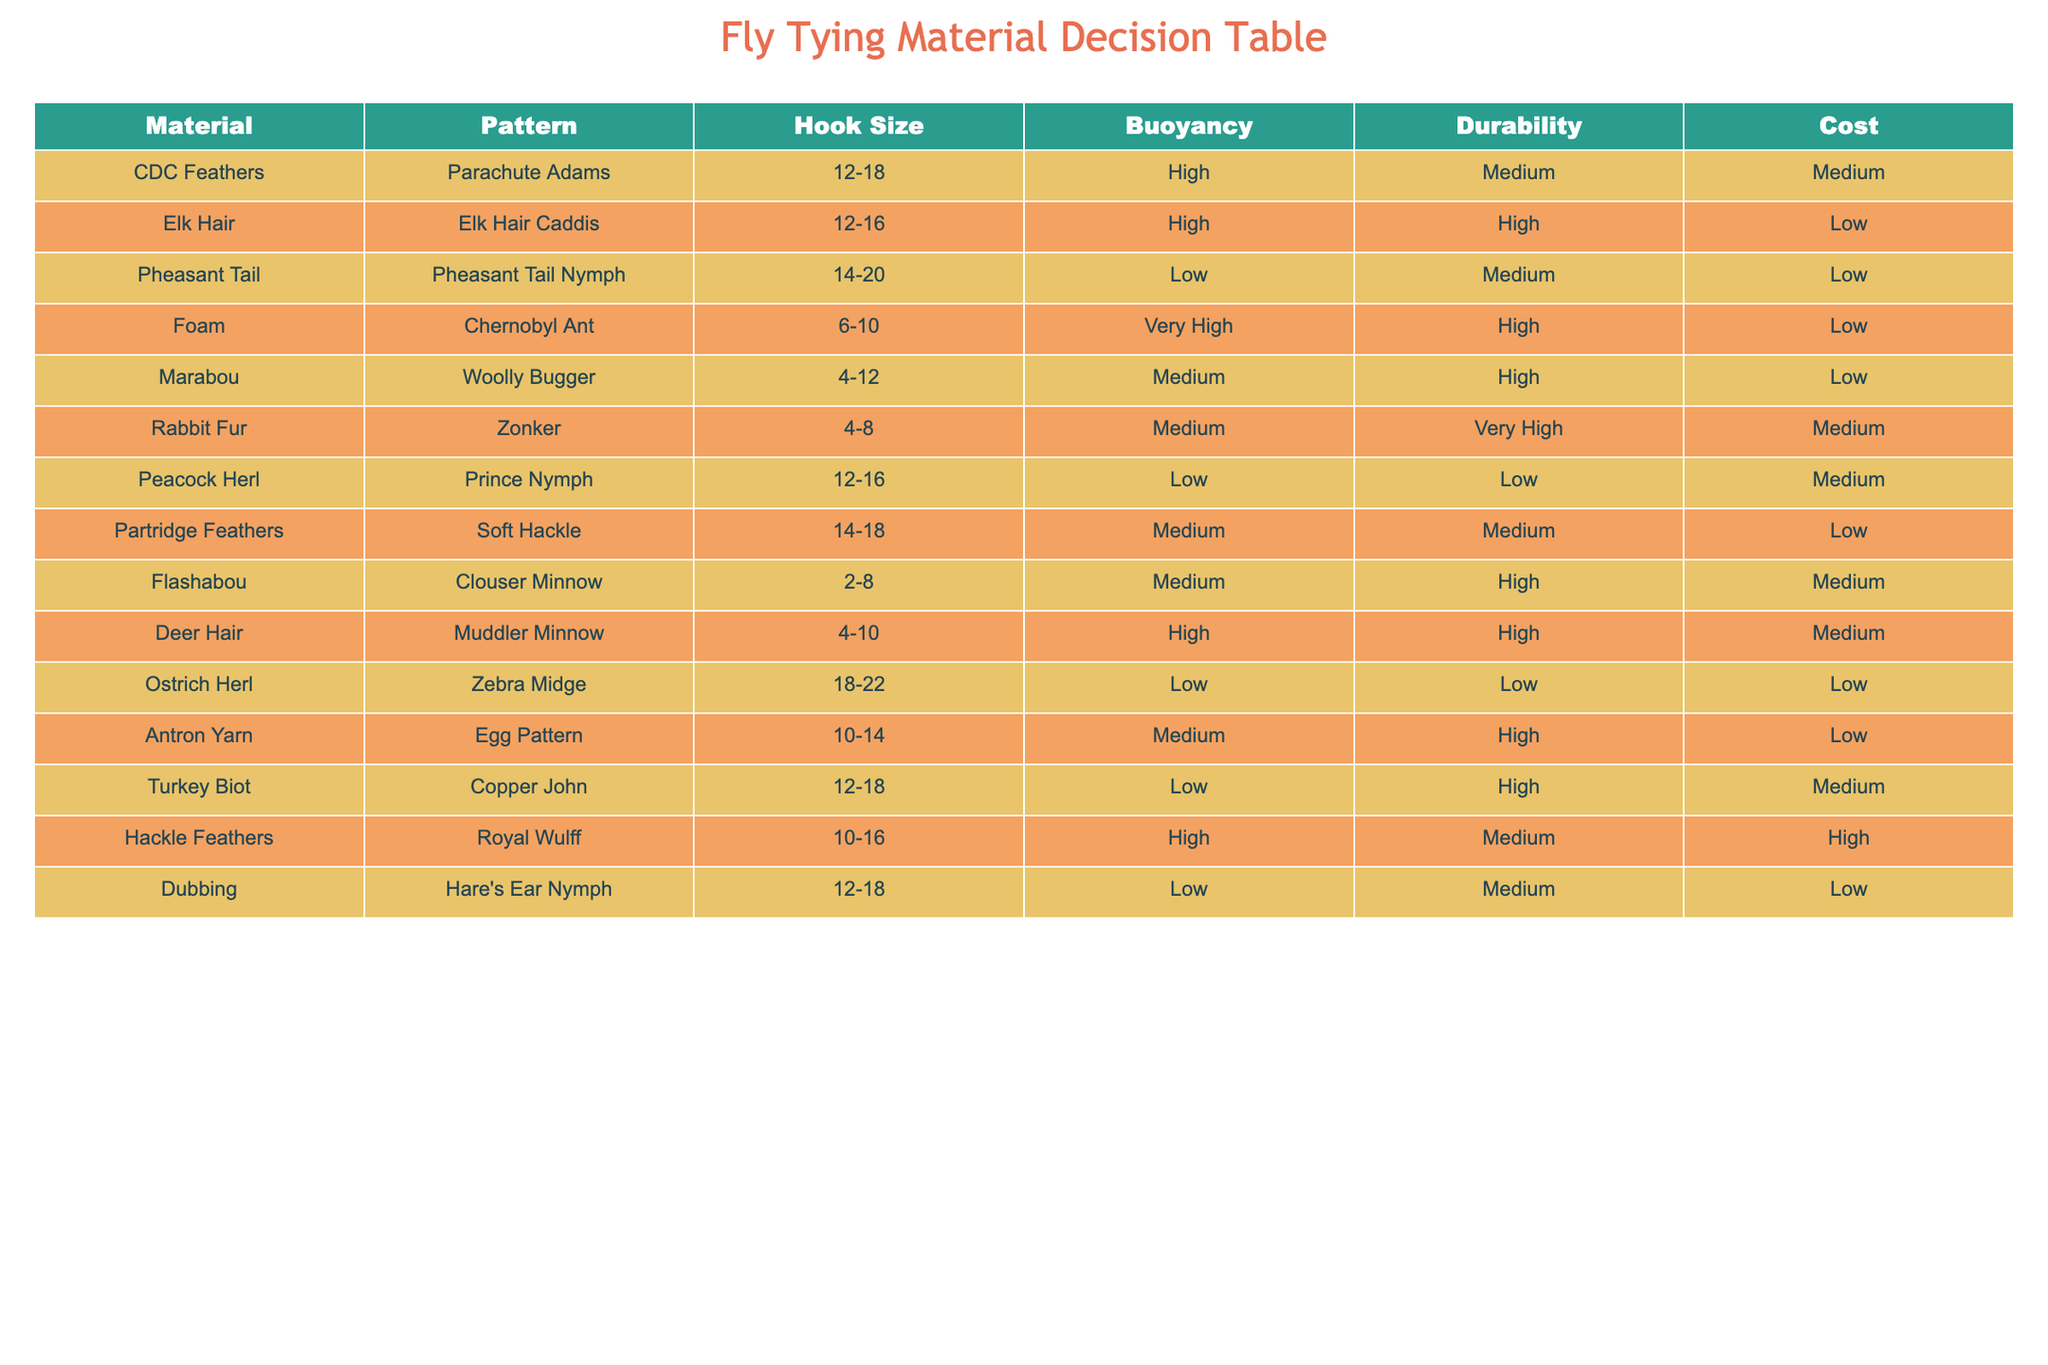What are the hook sizes for the Parachute Adams pattern? The table shows that the hook sizes for the Parachute Adams pattern are listed as 12-18.
Answer: 12-18 Which fly pattern has the highest buoyancy? Looking at the buoyancy ratings in the table, the Chernobyl Ant has a 'Very High' rating, which is the highest among all patterns listed.
Answer: Chernobyl Ant Is Elk Hair a high-durability material suitable for making the Elk Hair Caddis? The table indicates that Elk Hair has a durability rating of 'High', which confirms that it is suitable for making the Elk Hair Caddis.
Answer: Yes How many patterns have low cost materials? By examining the cost column, the following patterns have a low cost: Pheasant Tail Nymph, Elk Hair Caddis, Zebra Midge, and Dubbing. This totals to four patterns.
Answer: 4 What is the average durability rating for patterns that use CDC Feathers and Marabou? CDC Feathers have a durability rating of 'Medium' and Marabou has a 'High' rating. Converting these ratings: Low=1, Medium=2, High=3, we sum up (2 + 3 = 5) and divide by 2 to find the average durability rating, which is 2.5 or 'Medium-High'.
Answer: Medium-High Which materials are used for patterns that have 'Low' buoyancy? The patterns with 'Low' buoyancy in the table are Pheasant Tail Nymph, Peacock Herl, and Zebra Midge. Therefore, the materials are Pheasant Tail, Peacock Herl, and Ostrich Herl.
Answer: Pheasant Tail, Peacock Herl, Ostrich Herl Is there a pattern with both high durability and low cost? By reviewing the table, the Elk Hair Caddis has a high durability rating and a low cost, confirming that such a pattern exists.
Answer: Yes What is the total number of patterns listed that use Rabbit Fur? The table shows that there is only one pattern that uses Rabbit Fur, which is the Zonker.
Answer: 1 